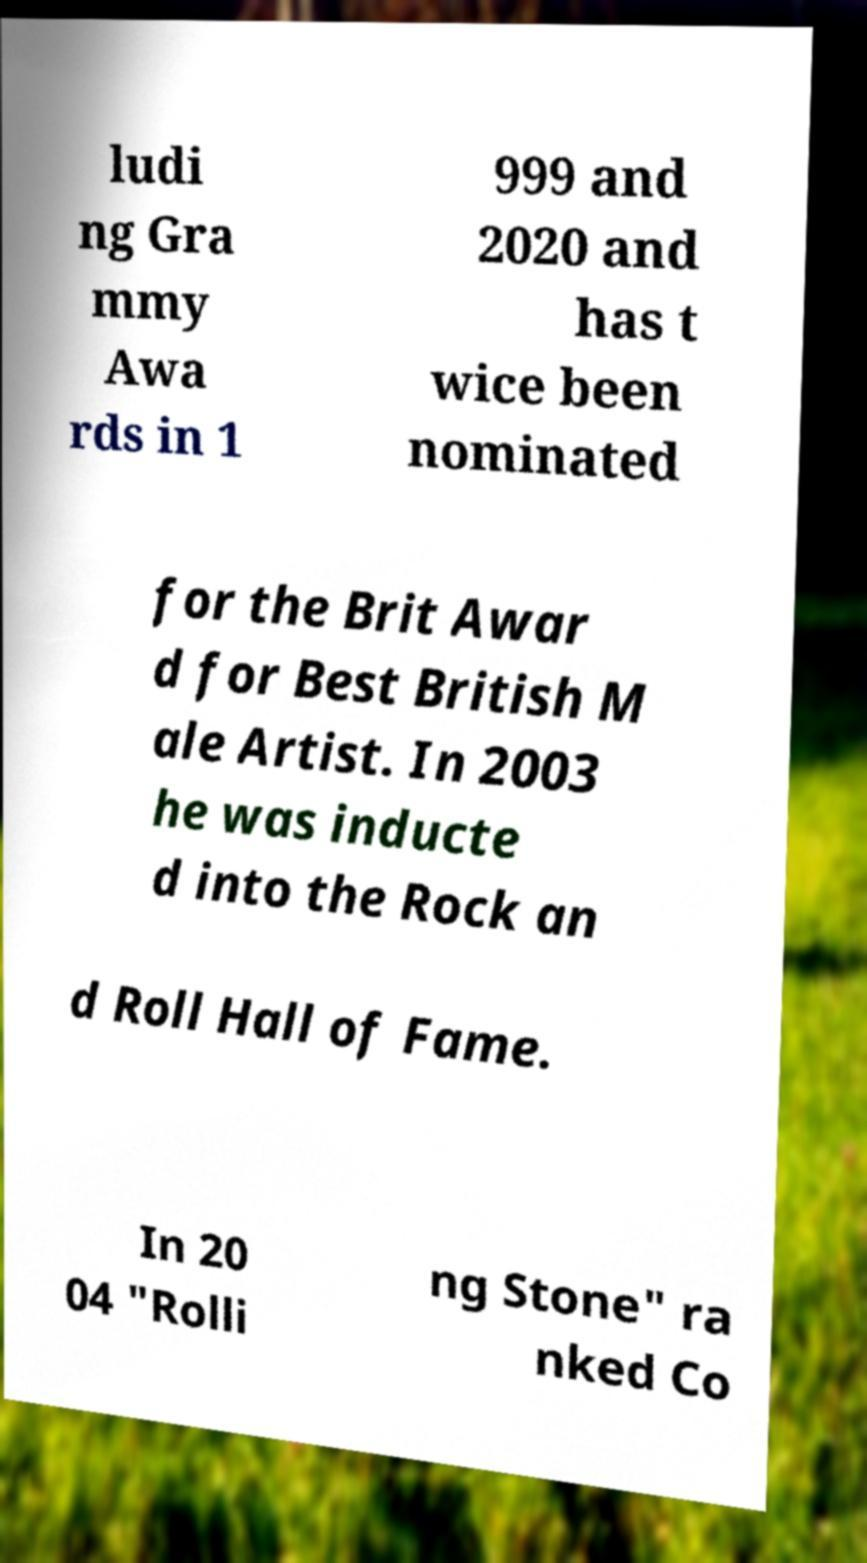Can you accurately transcribe the text from the provided image for me? ludi ng Gra mmy Awa rds in 1 999 and 2020 and has t wice been nominated for the Brit Awar d for Best British M ale Artist. In 2003 he was inducte d into the Rock an d Roll Hall of Fame. In 20 04 "Rolli ng Stone" ra nked Co 